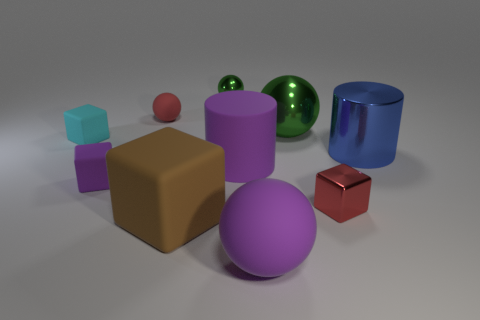How many things are either green spheres that are to the right of the large purple cylinder or big things that are in front of the purple cube?
Give a very brief answer. 3. There is a tiny red metal thing; what shape is it?
Your response must be concise. Cube. There is a large rubber thing that is the same color as the large matte sphere; what is its shape?
Your response must be concise. Cylinder. How many big purple things have the same material as the small purple thing?
Keep it short and to the point. 2. What color is the big cube?
Ensure brevity in your answer.  Brown. There is a shiny sphere that is the same size as the cyan object; what is its color?
Offer a terse response. Green. Are there any tiny shiny cylinders of the same color as the large block?
Offer a very short reply. No. There is a big metallic thing to the right of the tiny red shiny block; is it the same shape as the large metal thing that is behind the tiny cyan rubber thing?
Make the answer very short. No. What size is the rubber sphere that is the same color as the metallic block?
Make the answer very short. Small. How many other objects are the same size as the blue thing?
Provide a short and direct response. 4. 